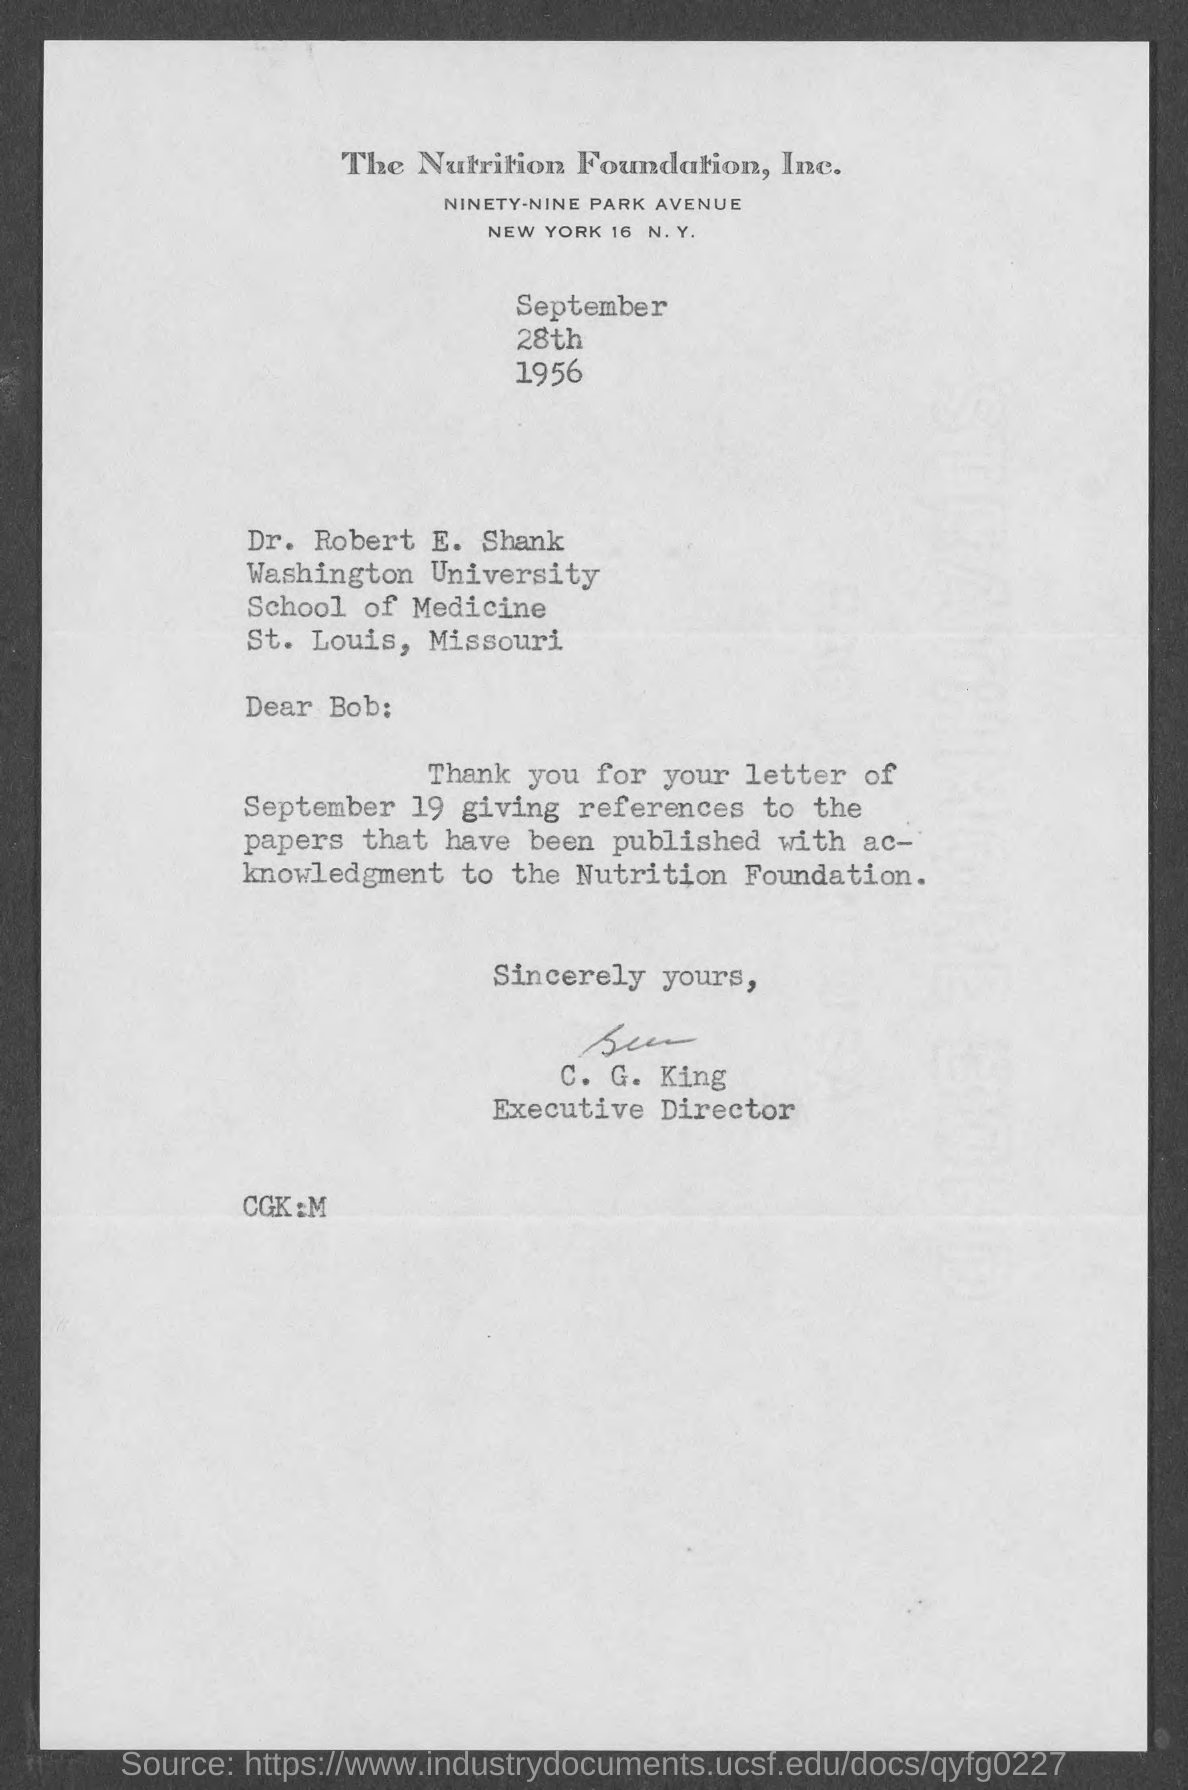What is the date on the document?
Provide a succinct answer. September 28th 1956. To Whom is this letter addressed to?
Your response must be concise. Dr. Robert E. Shank. Who is this letter from?
Your response must be concise. C. G. King. 